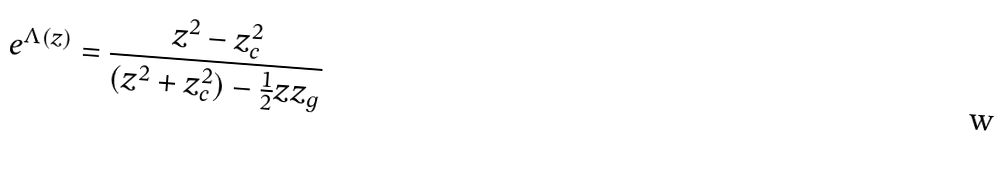<formula> <loc_0><loc_0><loc_500><loc_500>e ^ { \Lambda ( z ) } = \frac { z ^ { 2 } - z _ { c } ^ { 2 } } { ( z ^ { 2 } + z _ { c } ^ { 2 } ) - \frac { 1 } { 2 } z z _ { g } }</formula> 